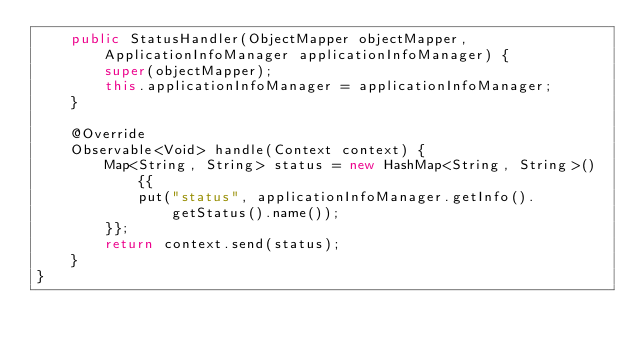<code> <loc_0><loc_0><loc_500><loc_500><_Java_>    public StatusHandler(ObjectMapper objectMapper, ApplicationInfoManager applicationInfoManager) {
        super(objectMapper);
        this.applicationInfoManager = applicationInfoManager;
    }

    @Override
    Observable<Void> handle(Context context) {
        Map<String, String> status = new HashMap<String, String>() {{
            put("status", applicationInfoManager.getInfo().getStatus().name());
        }};
        return context.send(status);
    }
}
</code> 